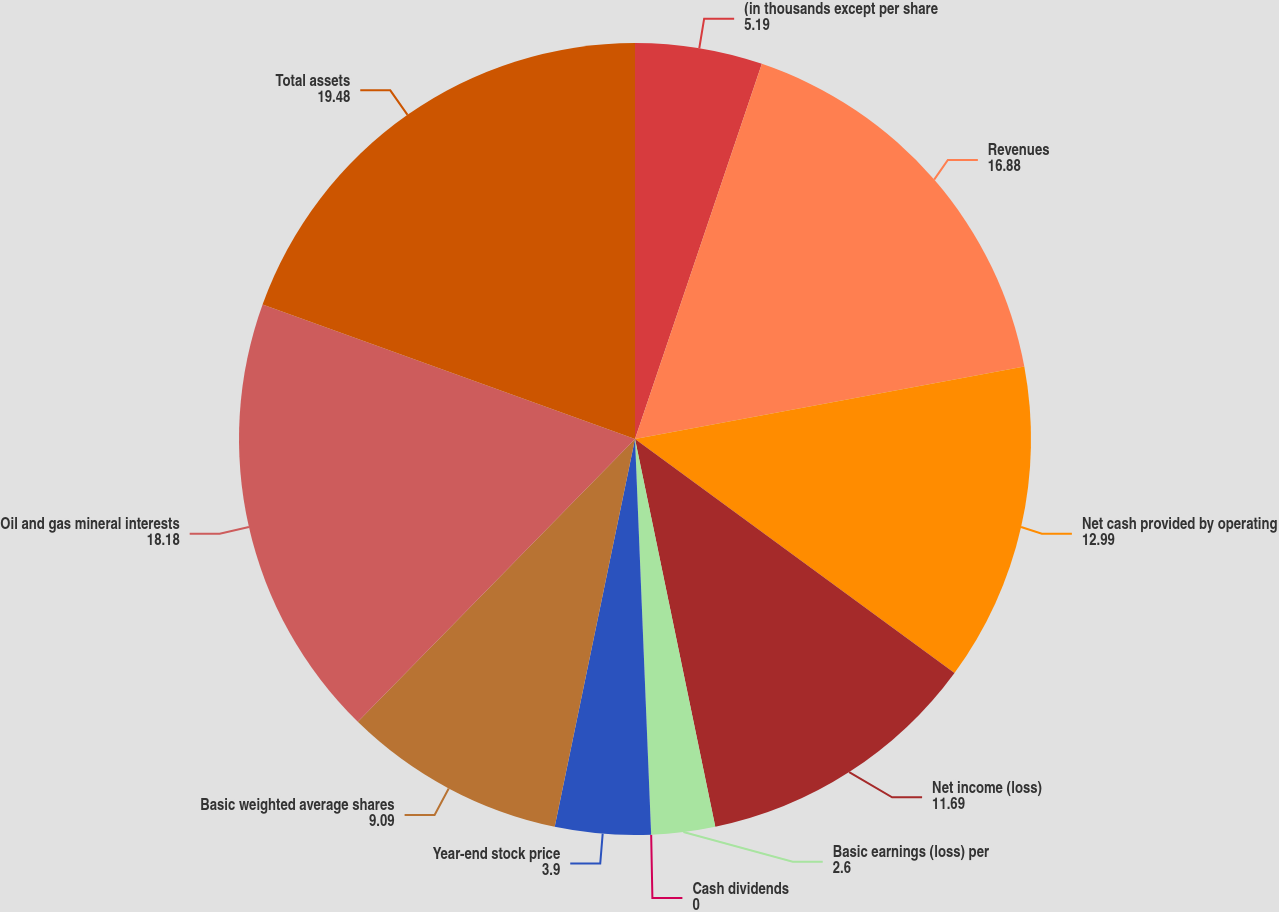<chart> <loc_0><loc_0><loc_500><loc_500><pie_chart><fcel>(in thousands except per share<fcel>Revenues<fcel>Net cash provided by operating<fcel>Net income (loss)<fcel>Basic earnings (loss) per<fcel>Cash dividends<fcel>Year-end stock price<fcel>Basic weighted average shares<fcel>Oil and gas mineral interests<fcel>Total assets<nl><fcel>5.19%<fcel>16.88%<fcel>12.99%<fcel>11.69%<fcel>2.6%<fcel>0.0%<fcel>3.9%<fcel>9.09%<fcel>18.18%<fcel>19.48%<nl></chart> 